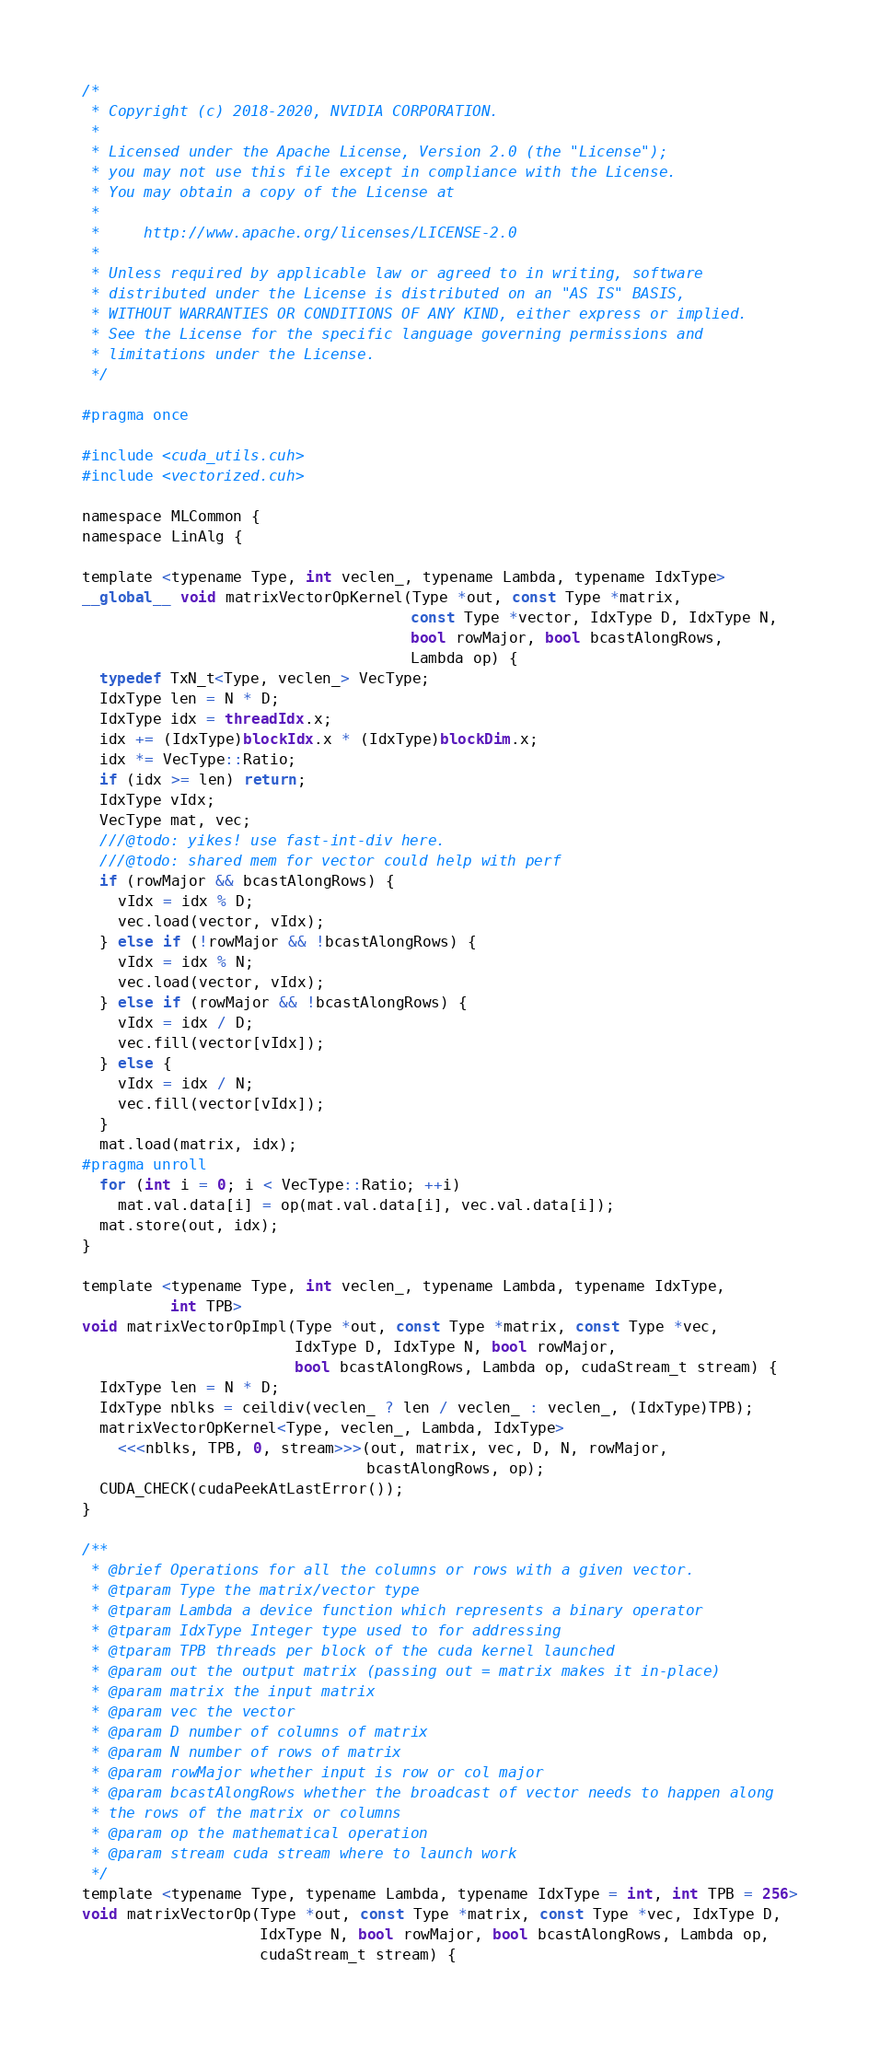Convert code to text. <code><loc_0><loc_0><loc_500><loc_500><_Cuda_>/*
 * Copyright (c) 2018-2020, NVIDIA CORPORATION.
 *
 * Licensed under the Apache License, Version 2.0 (the "License");
 * you may not use this file except in compliance with the License.
 * You may obtain a copy of the License at
 *
 *     http://www.apache.org/licenses/LICENSE-2.0
 *
 * Unless required by applicable law or agreed to in writing, software
 * distributed under the License is distributed on an "AS IS" BASIS,
 * WITHOUT WARRANTIES OR CONDITIONS OF ANY KIND, either express or implied.
 * See the License for the specific language governing permissions and
 * limitations under the License.
 */

#pragma once

#include <cuda_utils.cuh>
#include <vectorized.cuh>

namespace MLCommon {
namespace LinAlg {

template <typename Type, int veclen_, typename Lambda, typename IdxType>
__global__ void matrixVectorOpKernel(Type *out, const Type *matrix,
                                     const Type *vector, IdxType D, IdxType N,
                                     bool rowMajor, bool bcastAlongRows,
                                     Lambda op) {
  typedef TxN_t<Type, veclen_> VecType;
  IdxType len = N * D;
  IdxType idx = threadIdx.x;
  idx += (IdxType)blockIdx.x * (IdxType)blockDim.x;
  idx *= VecType::Ratio;
  if (idx >= len) return;
  IdxType vIdx;
  VecType mat, vec;
  ///@todo: yikes! use fast-int-div here.
  ///@todo: shared mem for vector could help with perf
  if (rowMajor && bcastAlongRows) {
    vIdx = idx % D;
    vec.load(vector, vIdx);
  } else if (!rowMajor && !bcastAlongRows) {
    vIdx = idx % N;
    vec.load(vector, vIdx);
  } else if (rowMajor && !bcastAlongRows) {
    vIdx = idx / D;
    vec.fill(vector[vIdx]);
  } else {
    vIdx = idx / N;
    vec.fill(vector[vIdx]);
  }
  mat.load(matrix, idx);
#pragma unroll
  for (int i = 0; i < VecType::Ratio; ++i)
    mat.val.data[i] = op(mat.val.data[i], vec.val.data[i]);
  mat.store(out, idx);
}

template <typename Type, int veclen_, typename Lambda, typename IdxType,
          int TPB>
void matrixVectorOpImpl(Type *out, const Type *matrix, const Type *vec,
                        IdxType D, IdxType N, bool rowMajor,
                        bool bcastAlongRows, Lambda op, cudaStream_t stream) {
  IdxType len = N * D;
  IdxType nblks = ceildiv(veclen_ ? len / veclen_ : veclen_, (IdxType)TPB);
  matrixVectorOpKernel<Type, veclen_, Lambda, IdxType>
    <<<nblks, TPB, 0, stream>>>(out, matrix, vec, D, N, rowMajor,
                                bcastAlongRows, op);
  CUDA_CHECK(cudaPeekAtLastError());
}

/**
 * @brief Operations for all the columns or rows with a given vector.
 * @tparam Type the matrix/vector type
 * @tparam Lambda a device function which represents a binary operator
 * @tparam IdxType Integer type used to for addressing
 * @tparam TPB threads per block of the cuda kernel launched
 * @param out the output matrix (passing out = matrix makes it in-place)
 * @param matrix the input matrix
 * @param vec the vector
 * @param D number of columns of matrix
 * @param N number of rows of matrix
 * @param rowMajor whether input is row or col major
 * @param bcastAlongRows whether the broadcast of vector needs to happen along
 * the rows of the matrix or columns
 * @param op the mathematical operation
 * @param stream cuda stream where to launch work
 */
template <typename Type, typename Lambda, typename IdxType = int, int TPB = 256>
void matrixVectorOp(Type *out, const Type *matrix, const Type *vec, IdxType D,
                    IdxType N, bool rowMajor, bool bcastAlongRows, Lambda op,
                    cudaStream_t stream) {</code> 